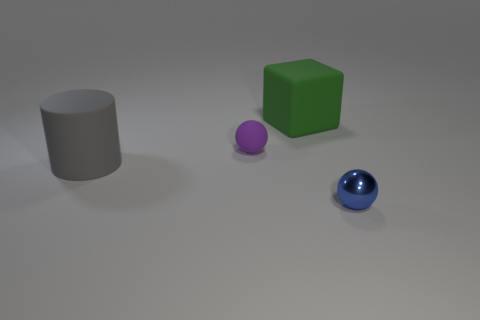Add 1 big cyan matte cubes. How many objects exist? 5 Subtract all cylinders. How many objects are left? 3 Add 3 large green objects. How many large green objects are left? 4 Add 2 big gray cylinders. How many big gray cylinders exist? 3 Subtract 0 yellow cylinders. How many objects are left? 4 Subtract all large gray rubber cylinders. Subtract all small blue metallic spheres. How many objects are left? 2 